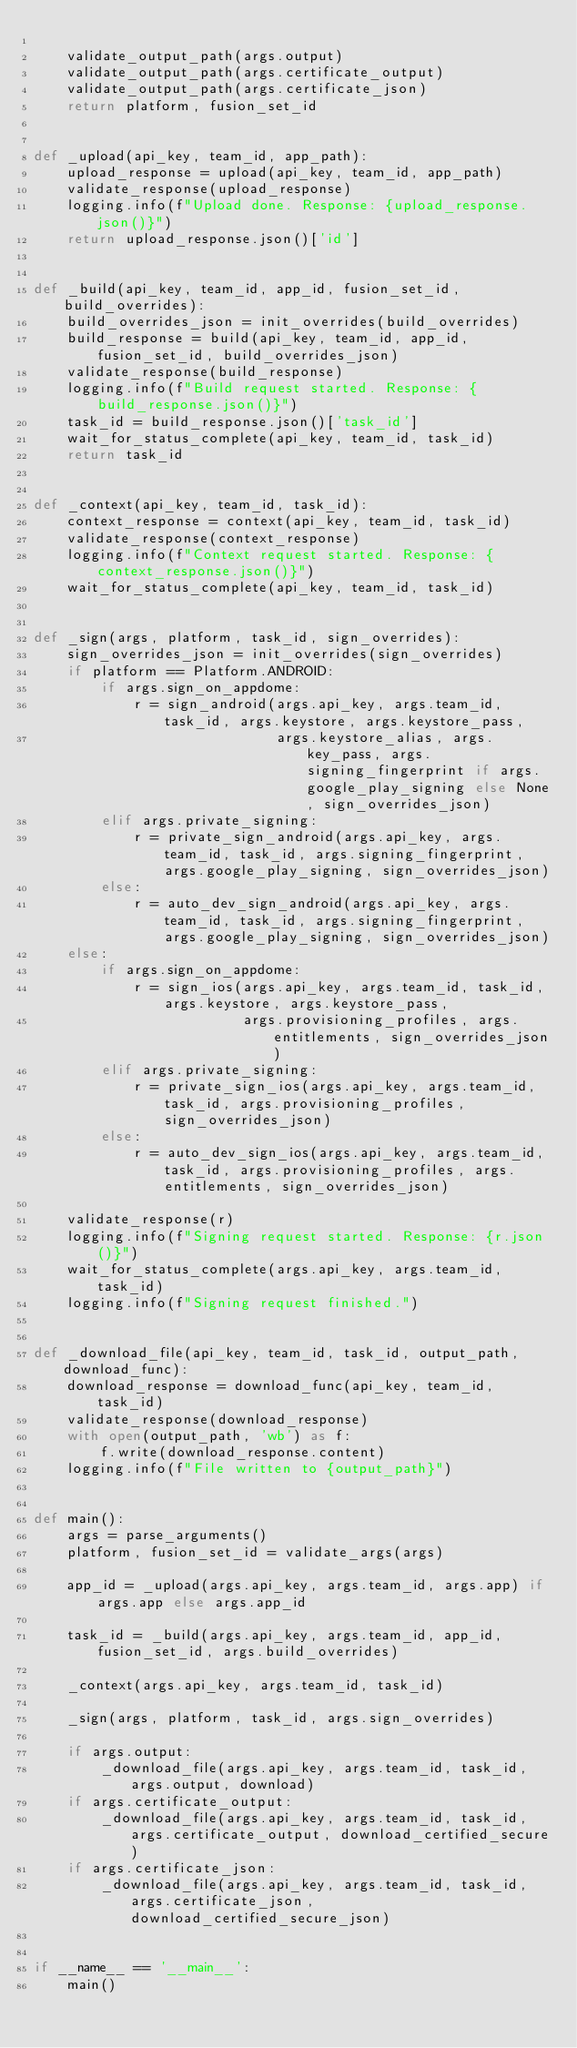Convert code to text. <code><loc_0><loc_0><loc_500><loc_500><_Python_>
    validate_output_path(args.output)
    validate_output_path(args.certificate_output)
    validate_output_path(args.certificate_json)
    return platform, fusion_set_id


def _upload(api_key, team_id, app_path):
    upload_response = upload(api_key, team_id, app_path)
    validate_response(upload_response)
    logging.info(f"Upload done. Response: {upload_response.json()}")
    return upload_response.json()['id']


def _build(api_key, team_id, app_id, fusion_set_id, build_overrides):
    build_overrides_json = init_overrides(build_overrides)
    build_response = build(api_key, team_id, app_id, fusion_set_id, build_overrides_json)
    validate_response(build_response)
    logging.info(f"Build request started. Response: {build_response.json()}")
    task_id = build_response.json()['task_id']
    wait_for_status_complete(api_key, team_id, task_id)
    return task_id


def _context(api_key, team_id, task_id):
    context_response = context(api_key, team_id, task_id)
    validate_response(context_response)
    logging.info(f"Context request started. Response: {context_response.json()}")
    wait_for_status_complete(api_key, team_id, task_id)


def _sign(args, platform, task_id, sign_overrides):
    sign_overrides_json = init_overrides(sign_overrides)
    if platform == Platform.ANDROID:
        if args.sign_on_appdome:
            r = sign_android(args.api_key, args.team_id, task_id, args.keystore, args.keystore_pass,
                             args.keystore_alias, args.key_pass, args.signing_fingerprint if args.google_play_signing else None, sign_overrides_json)
        elif args.private_signing:
            r = private_sign_android(args.api_key, args.team_id, task_id, args.signing_fingerprint, args.google_play_signing, sign_overrides_json)
        else:
            r = auto_dev_sign_android(args.api_key, args.team_id, task_id, args.signing_fingerprint, args.google_play_signing, sign_overrides_json)
    else:
        if args.sign_on_appdome:
            r = sign_ios(args.api_key, args.team_id, task_id, args.keystore, args.keystore_pass,
                         args.provisioning_profiles, args.entitlements, sign_overrides_json)
        elif args.private_signing:
            r = private_sign_ios(args.api_key, args.team_id, task_id, args.provisioning_profiles, sign_overrides_json)
        else:
            r = auto_dev_sign_ios(args.api_key, args.team_id, task_id, args.provisioning_profiles, args.entitlements, sign_overrides_json)

    validate_response(r)
    logging.info(f"Signing request started. Response: {r.json()}")
    wait_for_status_complete(args.api_key, args.team_id, task_id)
    logging.info(f"Signing request finished.")


def _download_file(api_key, team_id, task_id, output_path, download_func):
    download_response = download_func(api_key, team_id, task_id)
    validate_response(download_response)
    with open(output_path, 'wb') as f:
        f.write(download_response.content)
    logging.info(f"File written to {output_path}")


def main():
    args = parse_arguments()
    platform, fusion_set_id = validate_args(args)

    app_id = _upload(args.api_key, args.team_id, args.app) if args.app else args.app_id

    task_id = _build(args.api_key, args.team_id, app_id, fusion_set_id, args.build_overrides)

    _context(args.api_key, args.team_id, task_id)

    _sign(args, platform, task_id, args.sign_overrides)

    if args.output:
        _download_file(args.api_key, args.team_id, task_id, args.output, download)
    if args.certificate_output:
        _download_file(args.api_key, args.team_id, task_id, args.certificate_output, download_certified_secure)
    if args.certificate_json:
        _download_file(args.api_key, args.team_id, task_id, args.certificate_json, download_certified_secure_json)


if __name__ == '__main__':
    main()
</code> 